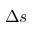<formula> <loc_0><loc_0><loc_500><loc_500>\Delta s</formula> 